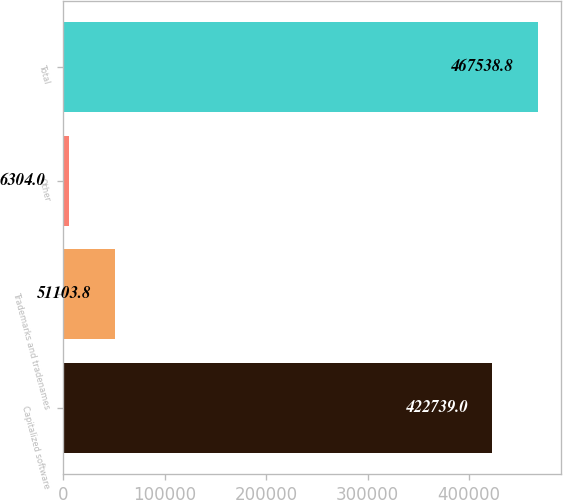Convert chart to OTSL. <chart><loc_0><loc_0><loc_500><loc_500><bar_chart><fcel>Capitalized software<fcel>Trademarks and tradenames<fcel>Other<fcel>Total<nl><fcel>422739<fcel>51103.8<fcel>6304<fcel>467539<nl></chart> 